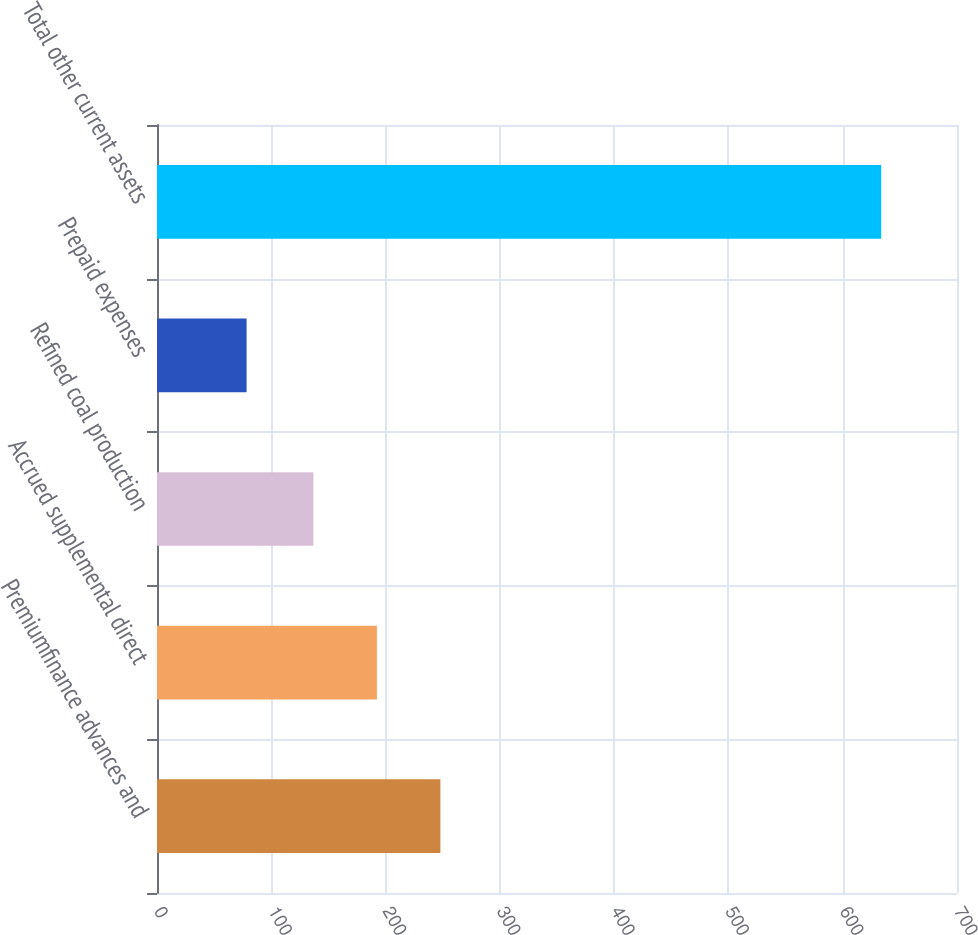Convert chart. <chart><loc_0><loc_0><loc_500><loc_500><bar_chart><fcel>Premiumfinance advances and<fcel>Accrued supplemental direct<fcel>Refined coal production<fcel>Prepaid expenses<fcel>Total other current assets<nl><fcel>247.96<fcel>192.43<fcel>136.9<fcel>78.4<fcel>633.7<nl></chart> 